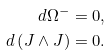Convert formula to latex. <formula><loc_0><loc_0><loc_500><loc_500>d \Omega ^ { - } & = 0 , \\ d \left ( J \wedge J \right ) & = 0 .</formula> 